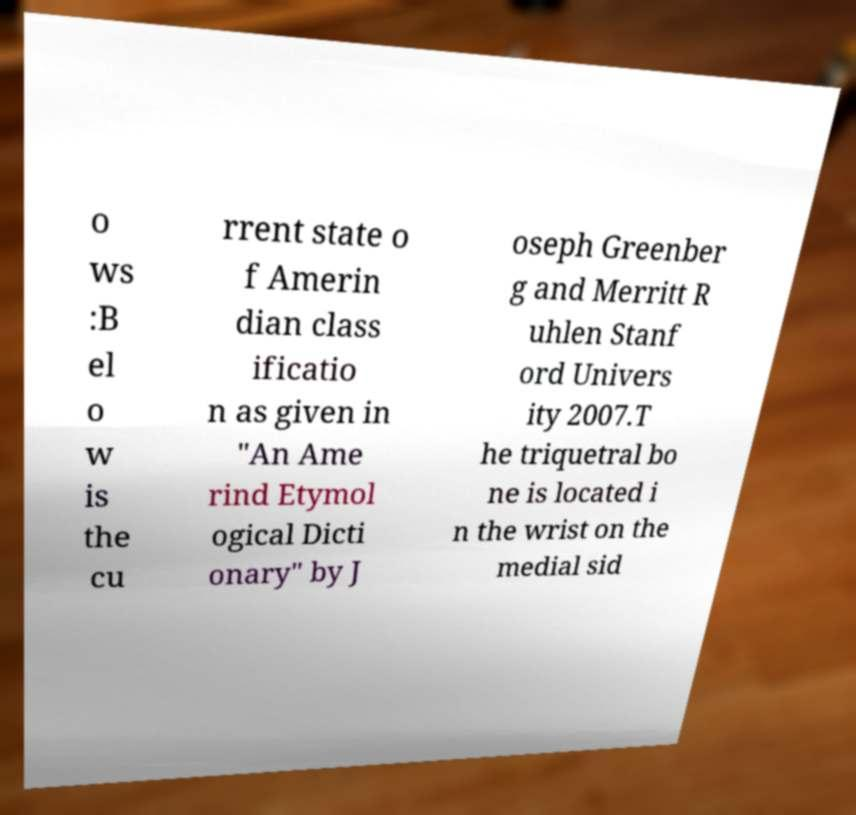I need the written content from this picture converted into text. Can you do that? o ws :B el o w is the cu rrent state o f Amerin dian class ificatio n as given in "An Ame rind Etymol ogical Dicti onary" by J oseph Greenber g and Merritt R uhlen Stanf ord Univers ity 2007.T he triquetral bo ne is located i n the wrist on the medial sid 